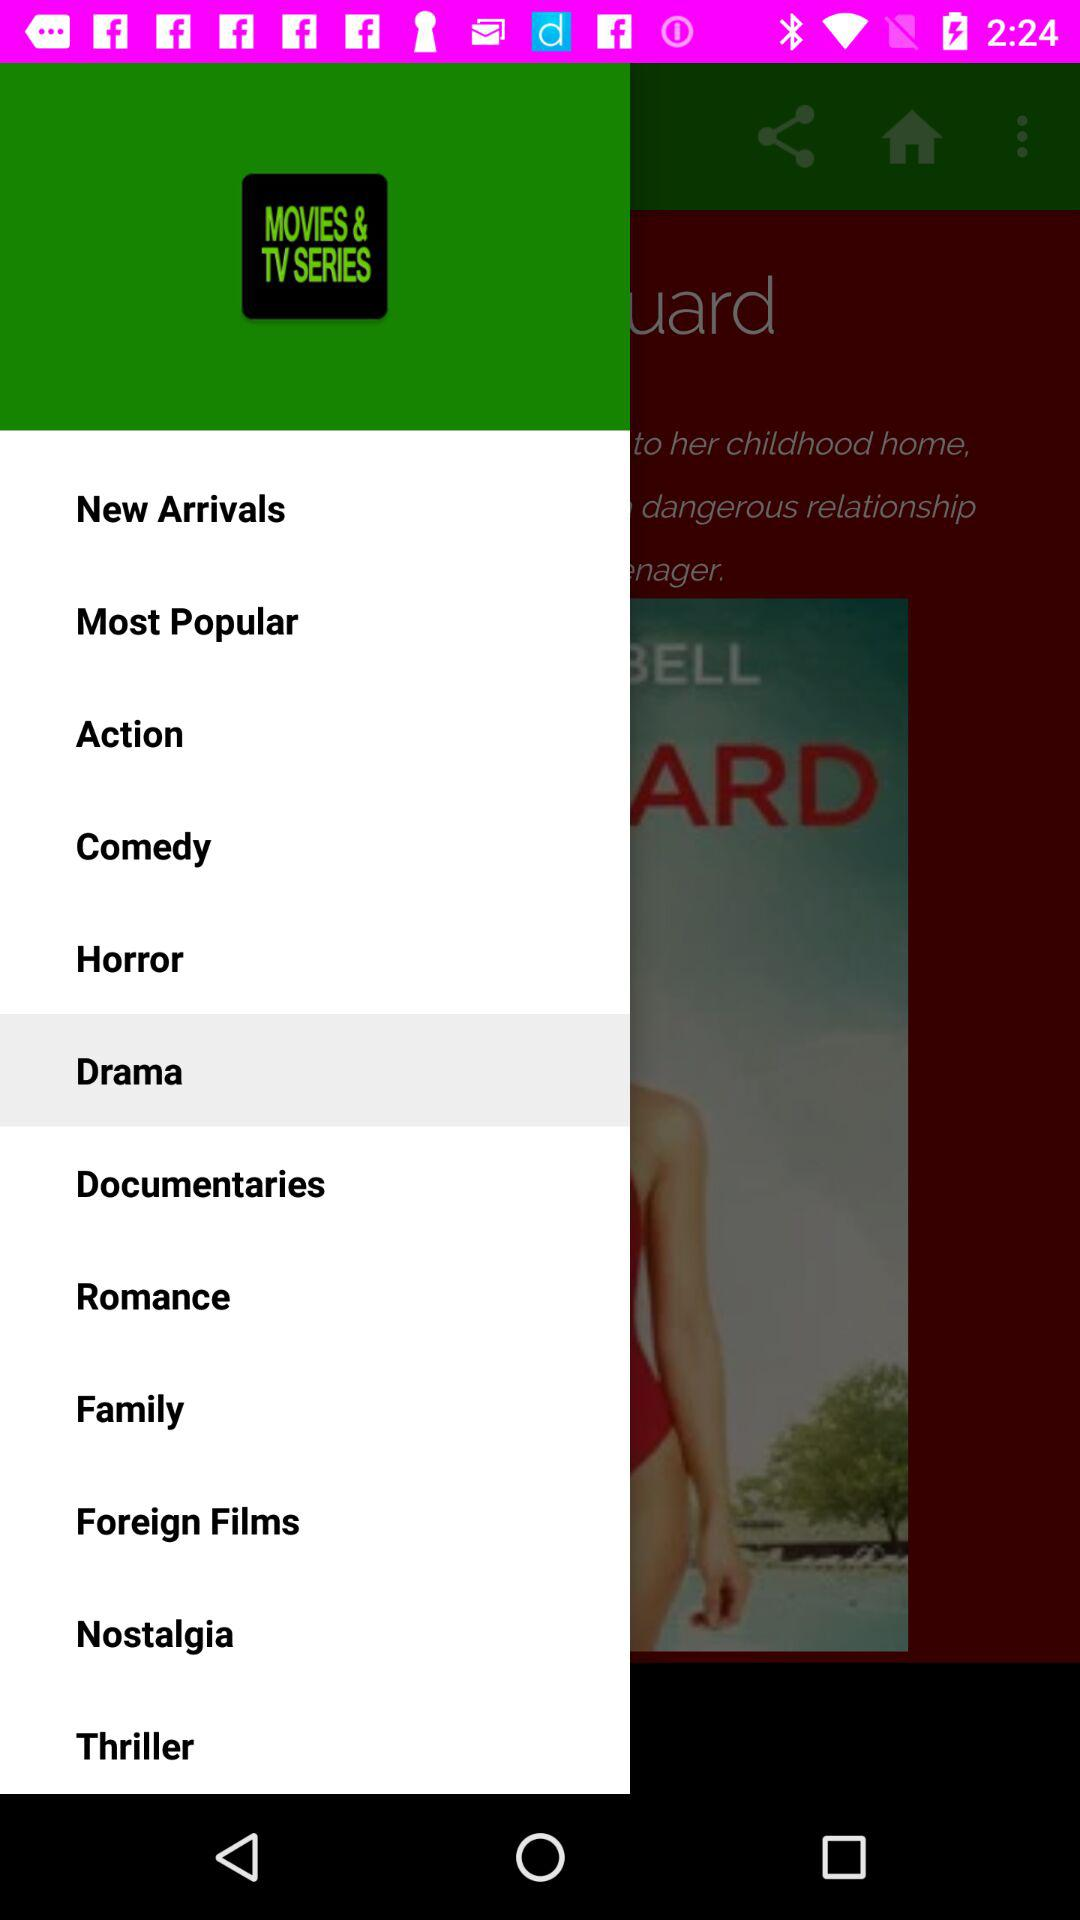How many movies are in the "Documentaries" category?
When the provided information is insufficient, respond with <no answer>. <no answer> 